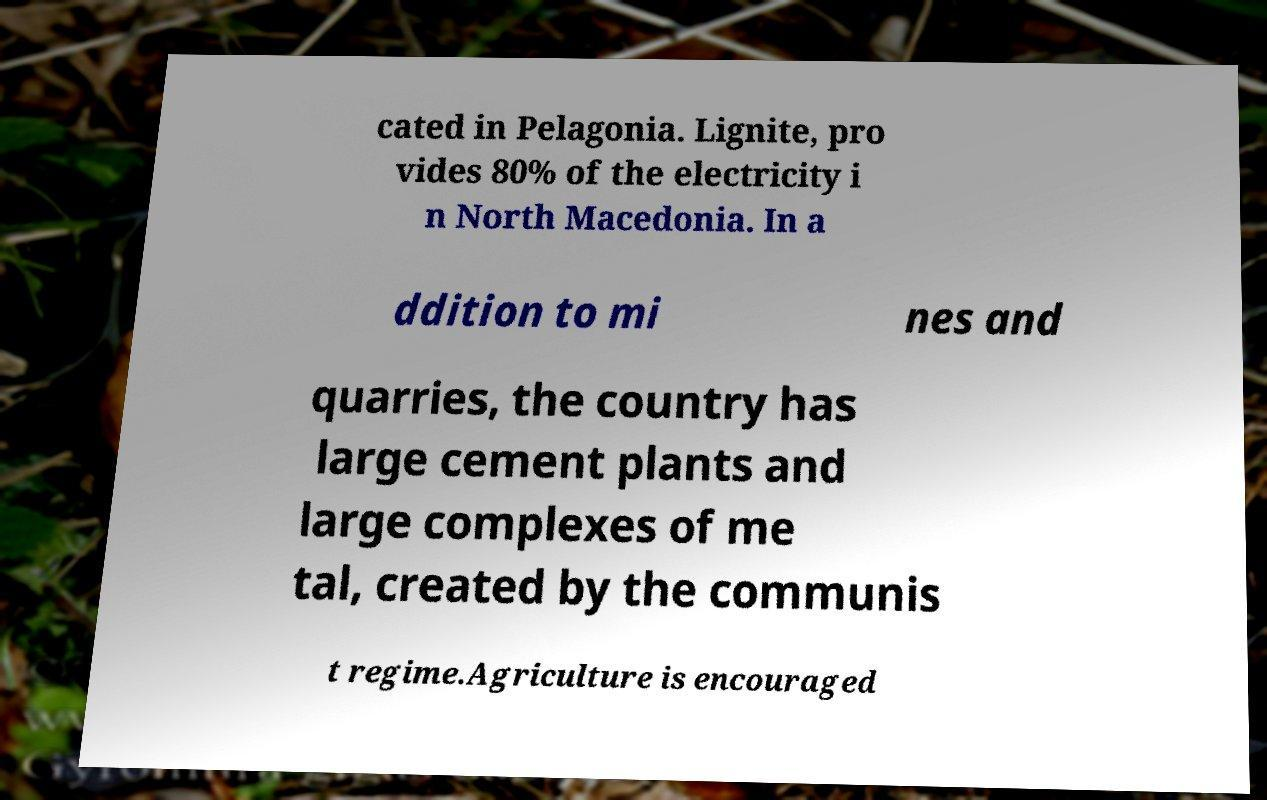Could you assist in decoding the text presented in this image and type it out clearly? cated in Pelagonia. Lignite, pro vides 80% of the electricity i n North Macedonia. In a ddition to mi nes and quarries, the country has large cement plants and large complexes of me tal, created by the communis t regime.Agriculture is encouraged 